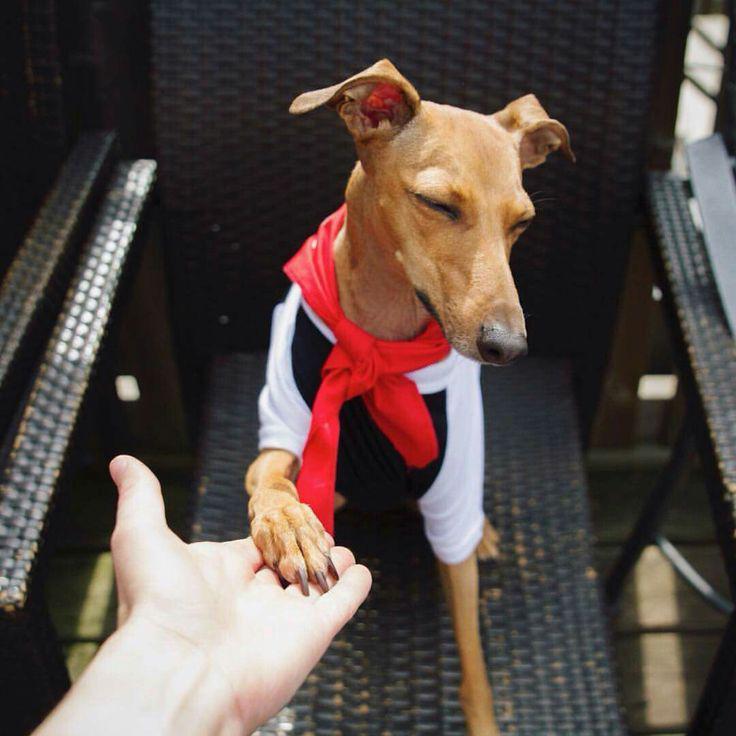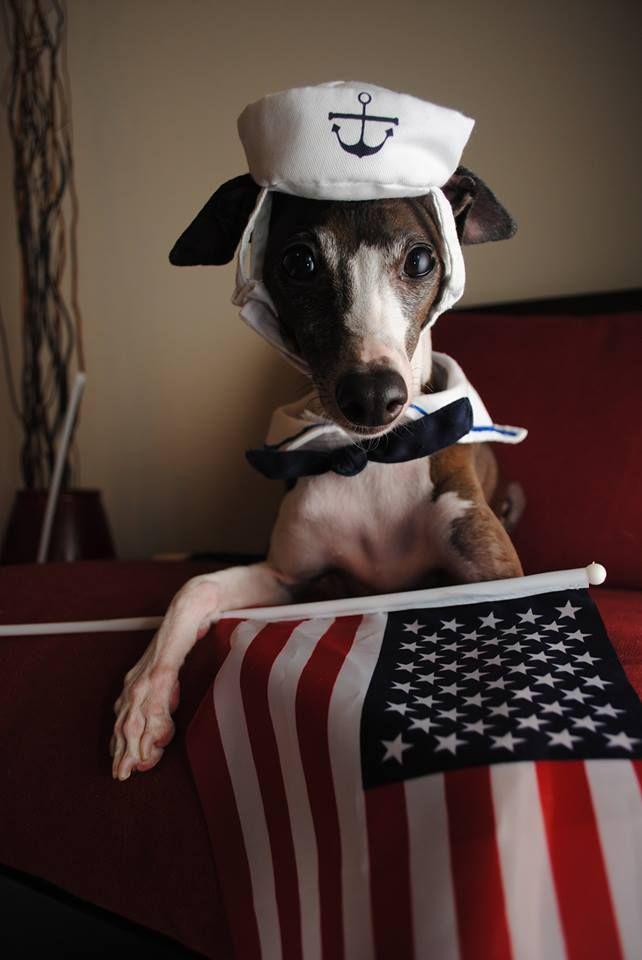The first image is the image on the left, the second image is the image on the right. Analyze the images presented: Is the assertion "At least one of the dogs has a hat on its head." valid? Answer yes or no. Yes. The first image is the image on the left, the second image is the image on the right. For the images displayed, is the sentence "One image features a hound wearing a hat, and no image shows more than one hound figure." factually correct? Answer yes or no. Yes. 